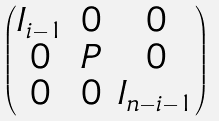<formula> <loc_0><loc_0><loc_500><loc_500>\begin{pmatrix} I _ { i - 1 } & 0 & 0 \\ 0 & P & 0 \\ 0 & 0 & I _ { n - i - 1 } \end{pmatrix}</formula> 